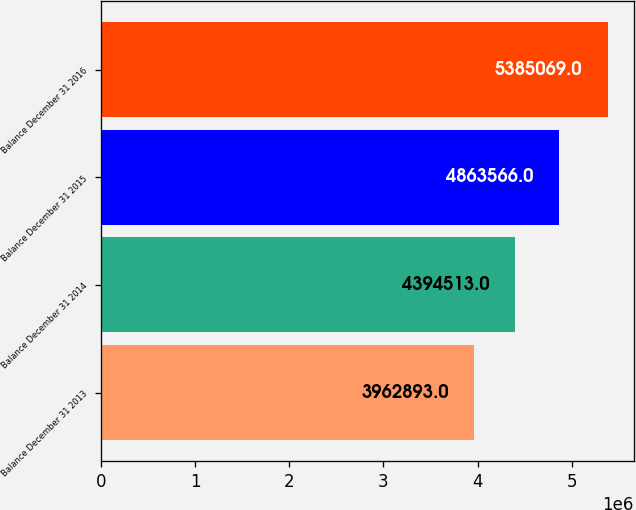Convert chart to OTSL. <chart><loc_0><loc_0><loc_500><loc_500><bar_chart><fcel>Balance December 31 2013<fcel>Balance December 31 2014<fcel>Balance December 31 2015<fcel>Balance December 31 2016<nl><fcel>3.96289e+06<fcel>4.39451e+06<fcel>4.86357e+06<fcel>5.38507e+06<nl></chart> 